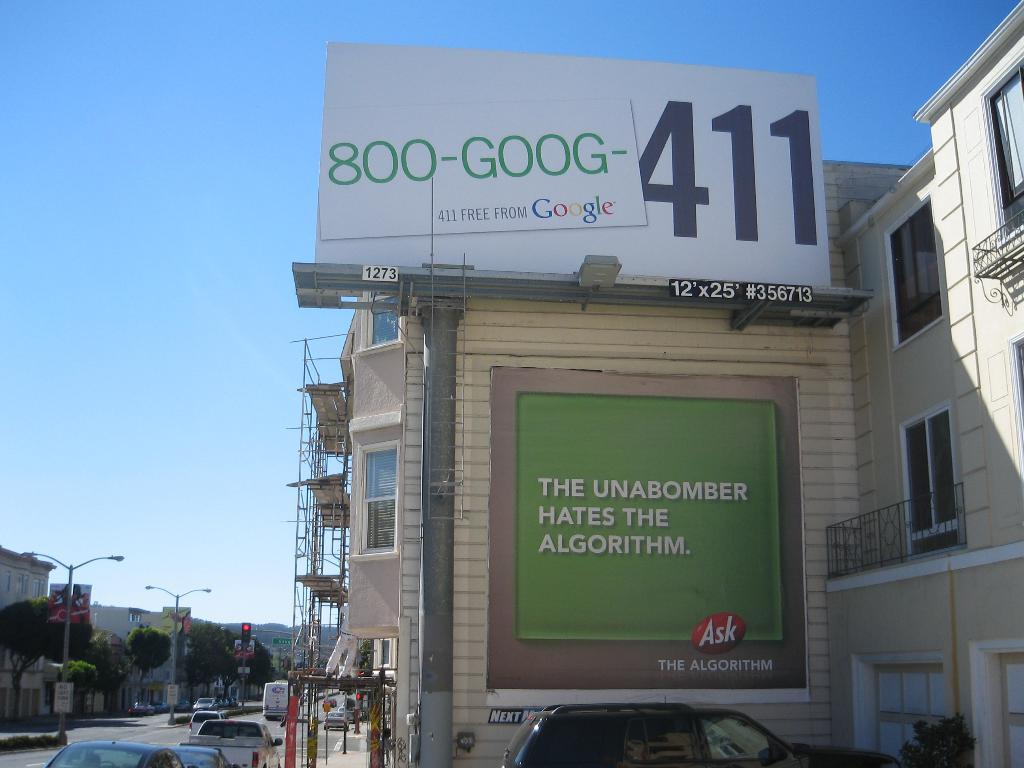<image>
Relay a brief, clear account of the picture shown. A busy city street with a giant billboard that says 411. 